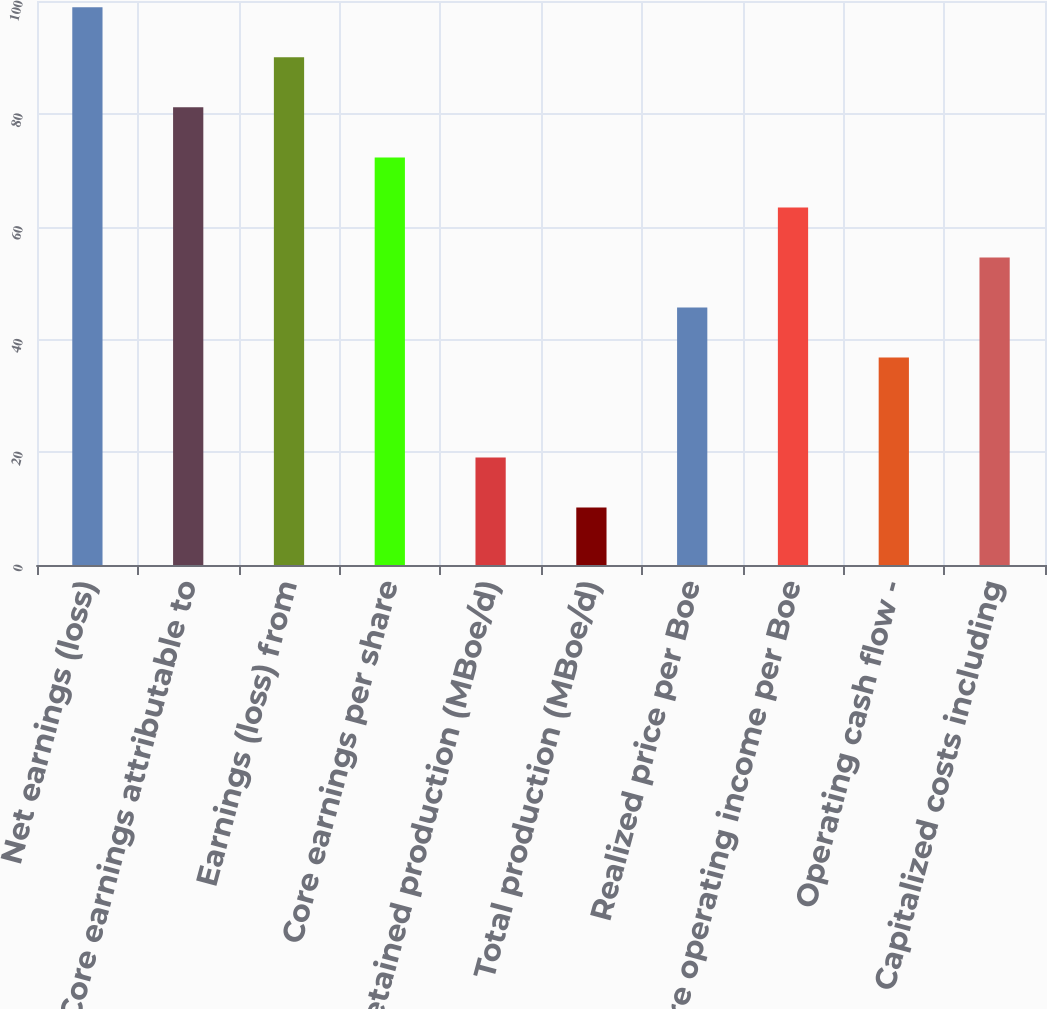Convert chart to OTSL. <chart><loc_0><loc_0><loc_500><loc_500><bar_chart><fcel>Net earnings (loss)<fcel>Core earnings attributable to<fcel>Earnings (loss) from<fcel>Core earnings per share<fcel>Retained production (MBoe/d)<fcel>Total production (MBoe/d)<fcel>Realized price per Boe<fcel>Core operating income per Boe<fcel>Operating cash flow -<fcel>Capitalized costs including<nl><fcel>98.88<fcel>81.14<fcel>90.01<fcel>72.27<fcel>19.05<fcel>10.18<fcel>45.66<fcel>63.4<fcel>36.79<fcel>54.53<nl></chart> 